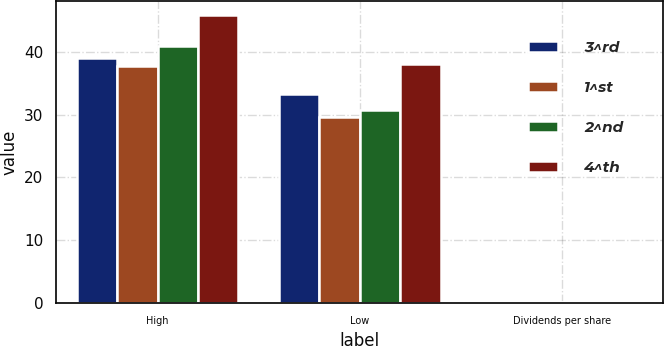Convert chart. <chart><loc_0><loc_0><loc_500><loc_500><stacked_bar_chart><ecel><fcel>High<fcel>Low<fcel>Dividends per share<nl><fcel>3^rd<fcel>38.99<fcel>33.21<fcel>0.11<nl><fcel>1^st<fcel>37.78<fcel>29.6<fcel>0.11<nl><fcel>2^nd<fcel>40.93<fcel>30.7<fcel>0.13<nl><fcel>4^th<fcel>45.81<fcel>38.01<fcel>0.13<nl></chart> 